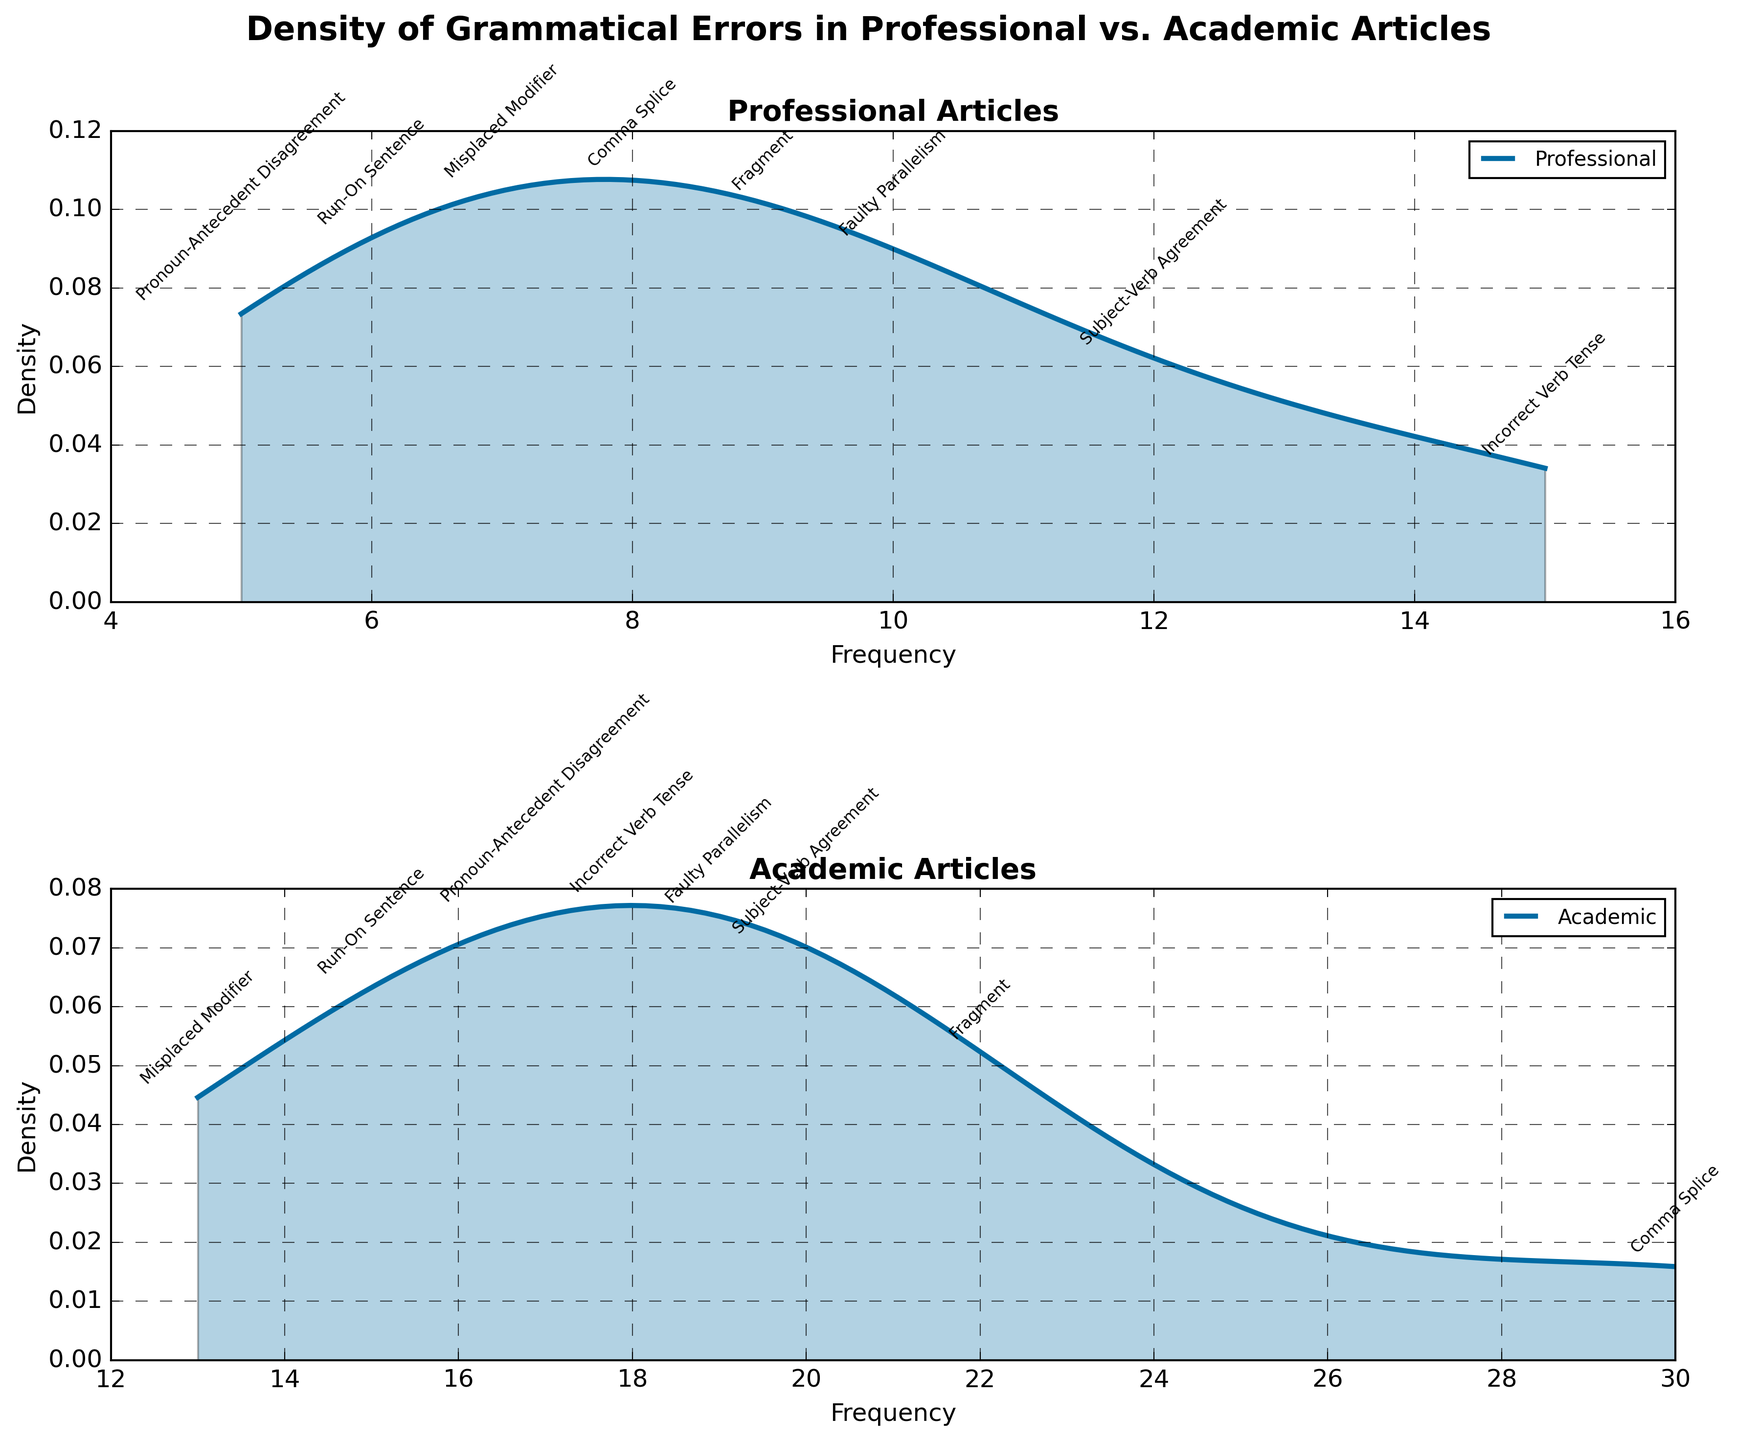What's the title of the figure? The title is located at the top of the figure, indicating what the plot is about.
Answer: Density of Grammatical Errors in Professional vs. Academic Articles How many subplots are there in the figure? The figure contains two subplots, one for each type of article (Professional and Academic)
Answer: Two Which subplot has a higher density peak for Subject-Verb Agreement errors? Looking at the peaks of the density plots in both subplots, the Academic Articles subplot has a higher density peak for Subject-Verb Agreement errors compared to the Professional Articles subplot.
Answer: Academic Articles What is the range of Frequency values used in the density plots? The x-axis, labeled "Frequency," shows the range from the minimum to maximum Frequency values from the data. The range is from 5 to 30.
Answer: 5 to 30 Which error type has the highest Frequency in Professional articles? By looking at the position of the highest frequency point on the x-axis in the Professional Articles subplot, the error type with the highest Frequency is Incorrect Verb Tense.
Answer: Incorrect Verb Tense Comparing the Frequency of Run-On Sentence errors, which article type has a higher frequency? By comparing the annotated Frequency values of Run-On Sentence errors in both subplots, Academic Articles have a higher Frequency (15 vs. 6).
Answer: Academic Articles What is the difference in Frequency of Fragment errors between Professional and Academic articles? The Frequency of Fragment errors is 9 for Professional articles and 22 for Academic articles. The difference can be calculated as 22 - 9 = 13.
Answer: 13 Which article type has a more diverse spread of Comma Splice errors based on the density plot? The density plot for Academic Articles shows a wider spread for Comma Splice errors, indicated by a broader density curve than that of Professional Articles.
Answer: Academic Articles What is the total Frequency of Misplaced Modifier errors for both article types combined? The Frequencies for Misplaced Modifier errors are 7 for Professional articles and 13 for Academic articles. The total Frequency is 7 + 13 = 20.
Answer: 20 In which article type do Pronoun-Antecedent Disagreement errors occur more frequently? The Academic Articles subplot shows Pronoun-Antecedent Disagreement errors with a higher frequency (17) compared to Professional Articles (5).
Answer: Academic Articles 